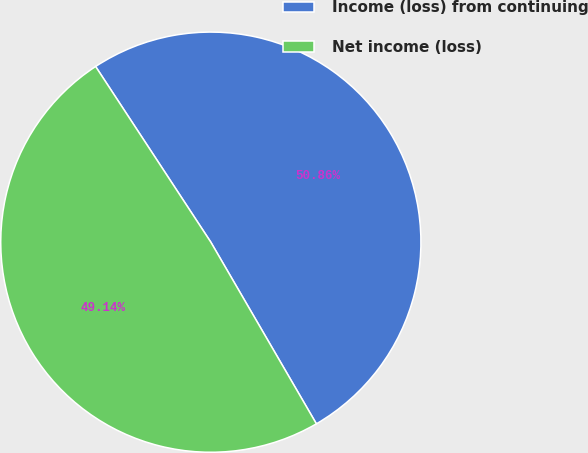Convert chart to OTSL. <chart><loc_0><loc_0><loc_500><loc_500><pie_chart><fcel>Income (loss) from continuing<fcel>Net income (loss)<nl><fcel>50.86%<fcel>49.14%<nl></chart> 